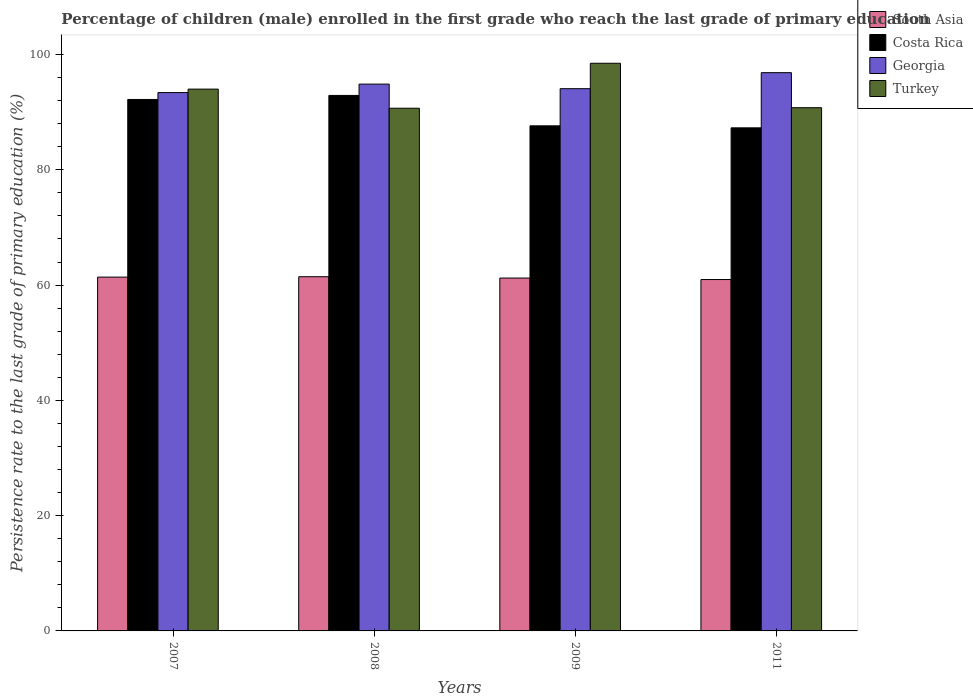Are the number of bars per tick equal to the number of legend labels?
Offer a terse response. Yes. Are the number of bars on each tick of the X-axis equal?
Offer a very short reply. Yes. In how many cases, is the number of bars for a given year not equal to the number of legend labels?
Your answer should be compact. 0. What is the persistence rate of children in Georgia in 2011?
Offer a very short reply. 96.86. Across all years, what is the maximum persistence rate of children in Turkey?
Your answer should be very brief. 98.49. Across all years, what is the minimum persistence rate of children in South Asia?
Give a very brief answer. 60.96. In which year was the persistence rate of children in Turkey maximum?
Offer a terse response. 2009. In which year was the persistence rate of children in Turkey minimum?
Ensure brevity in your answer.  2008. What is the total persistence rate of children in Georgia in the graph?
Make the answer very short. 379.2. What is the difference between the persistence rate of children in Georgia in 2007 and that in 2009?
Offer a very short reply. -0.68. What is the difference between the persistence rate of children in South Asia in 2008 and the persistence rate of children in Turkey in 2009?
Keep it short and to the point. -37.04. What is the average persistence rate of children in Georgia per year?
Ensure brevity in your answer.  94.8. In the year 2008, what is the difference between the persistence rate of children in Georgia and persistence rate of children in Costa Rica?
Provide a short and direct response. 1.96. What is the ratio of the persistence rate of children in Georgia in 2008 to that in 2011?
Ensure brevity in your answer.  0.98. Is the persistence rate of children in Turkey in 2008 less than that in 2009?
Your answer should be very brief. Yes. What is the difference between the highest and the second highest persistence rate of children in Georgia?
Your response must be concise. 1.99. What is the difference between the highest and the lowest persistence rate of children in Turkey?
Offer a terse response. 7.8. In how many years, is the persistence rate of children in Costa Rica greater than the average persistence rate of children in Costa Rica taken over all years?
Your answer should be very brief. 2. Is the sum of the persistence rate of children in Georgia in 2008 and 2009 greater than the maximum persistence rate of children in Costa Rica across all years?
Offer a terse response. Yes. What does the 3rd bar from the right in 2007 represents?
Your answer should be very brief. Costa Rica. Is it the case that in every year, the sum of the persistence rate of children in South Asia and persistence rate of children in Costa Rica is greater than the persistence rate of children in Turkey?
Your response must be concise. Yes. Are all the bars in the graph horizontal?
Give a very brief answer. No. How many years are there in the graph?
Your response must be concise. 4. What is the difference between two consecutive major ticks on the Y-axis?
Keep it short and to the point. 20. Does the graph contain any zero values?
Offer a terse response. No. Where does the legend appear in the graph?
Make the answer very short. Top right. How many legend labels are there?
Keep it short and to the point. 4. How are the legend labels stacked?
Your response must be concise. Vertical. What is the title of the graph?
Give a very brief answer. Percentage of children (male) enrolled in the first grade who reach the last grade of primary education. Does "Liechtenstein" appear as one of the legend labels in the graph?
Ensure brevity in your answer.  No. What is the label or title of the Y-axis?
Offer a very short reply. Persistence rate to the last grade of primary education (%). What is the Persistence rate to the last grade of primary education (%) of South Asia in 2007?
Your answer should be very brief. 61.38. What is the Persistence rate to the last grade of primary education (%) of Costa Rica in 2007?
Your response must be concise. 92.21. What is the Persistence rate to the last grade of primary education (%) of Georgia in 2007?
Make the answer very short. 93.4. What is the Persistence rate to the last grade of primary education (%) of Turkey in 2007?
Your answer should be compact. 94. What is the Persistence rate to the last grade of primary education (%) of South Asia in 2008?
Give a very brief answer. 61.45. What is the Persistence rate to the last grade of primary education (%) of Costa Rica in 2008?
Offer a terse response. 92.91. What is the Persistence rate to the last grade of primary education (%) in Georgia in 2008?
Your answer should be very brief. 94.87. What is the Persistence rate to the last grade of primary education (%) of Turkey in 2008?
Provide a succinct answer. 90.68. What is the Persistence rate to the last grade of primary education (%) of South Asia in 2009?
Make the answer very short. 61.22. What is the Persistence rate to the last grade of primary education (%) of Costa Rica in 2009?
Offer a very short reply. 87.63. What is the Persistence rate to the last grade of primary education (%) of Georgia in 2009?
Provide a succinct answer. 94.08. What is the Persistence rate to the last grade of primary education (%) in Turkey in 2009?
Offer a very short reply. 98.49. What is the Persistence rate to the last grade of primary education (%) in South Asia in 2011?
Your answer should be compact. 60.96. What is the Persistence rate to the last grade of primary education (%) of Costa Rica in 2011?
Provide a short and direct response. 87.28. What is the Persistence rate to the last grade of primary education (%) of Georgia in 2011?
Ensure brevity in your answer.  96.86. What is the Persistence rate to the last grade of primary education (%) in Turkey in 2011?
Your answer should be compact. 90.78. Across all years, what is the maximum Persistence rate to the last grade of primary education (%) in South Asia?
Your answer should be compact. 61.45. Across all years, what is the maximum Persistence rate to the last grade of primary education (%) in Costa Rica?
Your answer should be very brief. 92.91. Across all years, what is the maximum Persistence rate to the last grade of primary education (%) in Georgia?
Offer a terse response. 96.86. Across all years, what is the maximum Persistence rate to the last grade of primary education (%) of Turkey?
Provide a succinct answer. 98.49. Across all years, what is the minimum Persistence rate to the last grade of primary education (%) of South Asia?
Make the answer very short. 60.96. Across all years, what is the minimum Persistence rate to the last grade of primary education (%) of Costa Rica?
Provide a short and direct response. 87.28. Across all years, what is the minimum Persistence rate to the last grade of primary education (%) of Georgia?
Keep it short and to the point. 93.4. Across all years, what is the minimum Persistence rate to the last grade of primary education (%) of Turkey?
Your response must be concise. 90.68. What is the total Persistence rate to the last grade of primary education (%) of South Asia in the graph?
Make the answer very short. 245.02. What is the total Persistence rate to the last grade of primary education (%) in Costa Rica in the graph?
Make the answer very short. 360.03. What is the total Persistence rate to the last grade of primary education (%) of Georgia in the graph?
Your answer should be very brief. 379.2. What is the total Persistence rate to the last grade of primary education (%) in Turkey in the graph?
Your response must be concise. 373.95. What is the difference between the Persistence rate to the last grade of primary education (%) of South Asia in 2007 and that in 2008?
Keep it short and to the point. -0.07. What is the difference between the Persistence rate to the last grade of primary education (%) of Costa Rica in 2007 and that in 2008?
Ensure brevity in your answer.  -0.7. What is the difference between the Persistence rate to the last grade of primary education (%) in Georgia in 2007 and that in 2008?
Offer a very short reply. -1.47. What is the difference between the Persistence rate to the last grade of primary education (%) in Turkey in 2007 and that in 2008?
Your answer should be compact. 3.32. What is the difference between the Persistence rate to the last grade of primary education (%) of South Asia in 2007 and that in 2009?
Provide a succinct answer. 0.16. What is the difference between the Persistence rate to the last grade of primary education (%) in Costa Rica in 2007 and that in 2009?
Provide a short and direct response. 4.58. What is the difference between the Persistence rate to the last grade of primary education (%) in Georgia in 2007 and that in 2009?
Make the answer very short. -0.68. What is the difference between the Persistence rate to the last grade of primary education (%) of Turkey in 2007 and that in 2009?
Ensure brevity in your answer.  -4.49. What is the difference between the Persistence rate to the last grade of primary education (%) of South Asia in 2007 and that in 2011?
Make the answer very short. 0.42. What is the difference between the Persistence rate to the last grade of primary education (%) in Costa Rica in 2007 and that in 2011?
Give a very brief answer. 4.92. What is the difference between the Persistence rate to the last grade of primary education (%) in Georgia in 2007 and that in 2011?
Provide a short and direct response. -3.46. What is the difference between the Persistence rate to the last grade of primary education (%) of Turkey in 2007 and that in 2011?
Give a very brief answer. 3.23. What is the difference between the Persistence rate to the last grade of primary education (%) of South Asia in 2008 and that in 2009?
Make the answer very short. 0.23. What is the difference between the Persistence rate to the last grade of primary education (%) of Costa Rica in 2008 and that in 2009?
Your answer should be compact. 5.27. What is the difference between the Persistence rate to the last grade of primary education (%) of Georgia in 2008 and that in 2009?
Provide a short and direct response. 0.79. What is the difference between the Persistence rate to the last grade of primary education (%) in Turkey in 2008 and that in 2009?
Your answer should be very brief. -7.8. What is the difference between the Persistence rate to the last grade of primary education (%) of South Asia in 2008 and that in 2011?
Your answer should be very brief. 0.49. What is the difference between the Persistence rate to the last grade of primary education (%) in Costa Rica in 2008 and that in 2011?
Give a very brief answer. 5.62. What is the difference between the Persistence rate to the last grade of primary education (%) in Georgia in 2008 and that in 2011?
Keep it short and to the point. -1.99. What is the difference between the Persistence rate to the last grade of primary education (%) of Turkey in 2008 and that in 2011?
Ensure brevity in your answer.  -0.09. What is the difference between the Persistence rate to the last grade of primary education (%) of South Asia in 2009 and that in 2011?
Provide a succinct answer. 0.26. What is the difference between the Persistence rate to the last grade of primary education (%) of Costa Rica in 2009 and that in 2011?
Give a very brief answer. 0.35. What is the difference between the Persistence rate to the last grade of primary education (%) of Georgia in 2009 and that in 2011?
Make the answer very short. -2.78. What is the difference between the Persistence rate to the last grade of primary education (%) in Turkey in 2009 and that in 2011?
Make the answer very short. 7.71. What is the difference between the Persistence rate to the last grade of primary education (%) in South Asia in 2007 and the Persistence rate to the last grade of primary education (%) in Costa Rica in 2008?
Give a very brief answer. -31.52. What is the difference between the Persistence rate to the last grade of primary education (%) of South Asia in 2007 and the Persistence rate to the last grade of primary education (%) of Georgia in 2008?
Give a very brief answer. -33.49. What is the difference between the Persistence rate to the last grade of primary education (%) of South Asia in 2007 and the Persistence rate to the last grade of primary education (%) of Turkey in 2008?
Give a very brief answer. -29.3. What is the difference between the Persistence rate to the last grade of primary education (%) of Costa Rica in 2007 and the Persistence rate to the last grade of primary education (%) of Georgia in 2008?
Provide a succinct answer. -2.66. What is the difference between the Persistence rate to the last grade of primary education (%) in Costa Rica in 2007 and the Persistence rate to the last grade of primary education (%) in Turkey in 2008?
Make the answer very short. 1.52. What is the difference between the Persistence rate to the last grade of primary education (%) in Georgia in 2007 and the Persistence rate to the last grade of primary education (%) in Turkey in 2008?
Offer a very short reply. 2.71. What is the difference between the Persistence rate to the last grade of primary education (%) of South Asia in 2007 and the Persistence rate to the last grade of primary education (%) of Costa Rica in 2009?
Ensure brevity in your answer.  -26.25. What is the difference between the Persistence rate to the last grade of primary education (%) of South Asia in 2007 and the Persistence rate to the last grade of primary education (%) of Georgia in 2009?
Keep it short and to the point. -32.69. What is the difference between the Persistence rate to the last grade of primary education (%) in South Asia in 2007 and the Persistence rate to the last grade of primary education (%) in Turkey in 2009?
Your response must be concise. -37.1. What is the difference between the Persistence rate to the last grade of primary education (%) in Costa Rica in 2007 and the Persistence rate to the last grade of primary education (%) in Georgia in 2009?
Your answer should be compact. -1.87. What is the difference between the Persistence rate to the last grade of primary education (%) of Costa Rica in 2007 and the Persistence rate to the last grade of primary education (%) of Turkey in 2009?
Provide a short and direct response. -6.28. What is the difference between the Persistence rate to the last grade of primary education (%) of Georgia in 2007 and the Persistence rate to the last grade of primary education (%) of Turkey in 2009?
Provide a short and direct response. -5.09. What is the difference between the Persistence rate to the last grade of primary education (%) of South Asia in 2007 and the Persistence rate to the last grade of primary education (%) of Costa Rica in 2011?
Offer a very short reply. -25.9. What is the difference between the Persistence rate to the last grade of primary education (%) in South Asia in 2007 and the Persistence rate to the last grade of primary education (%) in Georgia in 2011?
Your answer should be compact. -35.47. What is the difference between the Persistence rate to the last grade of primary education (%) in South Asia in 2007 and the Persistence rate to the last grade of primary education (%) in Turkey in 2011?
Your answer should be very brief. -29.39. What is the difference between the Persistence rate to the last grade of primary education (%) of Costa Rica in 2007 and the Persistence rate to the last grade of primary education (%) of Georgia in 2011?
Offer a very short reply. -4.65. What is the difference between the Persistence rate to the last grade of primary education (%) in Costa Rica in 2007 and the Persistence rate to the last grade of primary education (%) in Turkey in 2011?
Provide a short and direct response. 1.43. What is the difference between the Persistence rate to the last grade of primary education (%) of Georgia in 2007 and the Persistence rate to the last grade of primary education (%) of Turkey in 2011?
Offer a terse response. 2.62. What is the difference between the Persistence rate to the last grade of primary education (%) of South Asia in 2008 and the Persistence rate to the last grade of primary education (%) of Costa Rica in 2009?
Offer a terse response. -26.18. What is the difference between the Persistence rate to the last grade of primary education (%) of South Asia in 2008 and the Persistence rate to the last grade of primary education (%) of Georgia in 2009?
Give a very brief answer. -32.63. What is the difference between the Persistence rate to the last grade of primary education (%) in South Asia in 2008 and the Persistence rate to the last grade of primary education (%) in Turkey in 2009?
Keep it short and to the point. -37.04. What is the difference between the Persistence rate to the last grade of primary education (%) in Costa Rica in 2008 and the Persistence rate to the last grade of primary education (%) in Georgia in 2009?
Give a very brief answer. -1.17. What is the difference between the Persistence rate to the last grade of primary education (%) of Costa Rica in 2008 and the Persistence rate to the last grade of primary education (%) of Turkey in 2009?
Ensure brevity in your answer.  -5.58. What is the difference between the Persistence rate to the last grade of primary education (%) of Georgia in 2008 and the Persistence rate to the last grade of primary education (%) of Turkey in 2009?
Make the answer very short. -3.62. What is the difference between the Persistence rate to the last grade of primary education (%) in South Asia in 2008 and the Persistence rate to the last grade of primary education (%) in Costa Rica in 2011?
Offer a very short reply. -25.83. What is the difference between the Persistence rate to the last grade of primary education (%) of South Asia in 2008 and the Persistence rate to the last grade of primary education (%) of Georgia in 2011?
Give a very brief answer. -35.4. What is the difference between the Persistence rate to the last grade of primary education (%) in South Asia in 2008 and the Persistence rate to the last grade of primary education (%) in Turkey in 2011?
Provide a short and direct response. -29.32. What is the difference between the Persistence rate to the last grade of primary education (%) in Costa Rica in 2008 and the Persistence rate to the last grade of primary education (%) in Georgia in 2011?
Your response must be concise. -3.95. What is the difference between the Persistence rate to the last grade of primary education (%) of Costa Rica in 2008 and the Persistence rate to the last grade of primary education (%) of Turkey in 2011?
Your answer should be very brief. 2.13. What is the difference between the Persistence rate to the last grade of primary education (%) of Georgia in 2008 and the Persistence rate to the last grade of primary education (%) of Turkey in 2011?
Ensure brevity in your answer.  4.1. What is the difference between the Persistence rate to the last grade of primary education (%) in South Asia in 2009 and the Persistence rate to the last grade of primary education (%) in Costa Rica in 2011?
Your answer should be very brief. -26.06. What is the difference between the Persistence rate to the last grade of primary education (%) in South Asia in 2009 and the Persistence rate to the last grade of primary education (%) in Georgia in 2011?
Provide a succinct answer. -35.63. What is the difference between the Persistence rate to the last grade of primary education (%) of South Asia in 2009 and the Persistence rate to the last grade of primary education (%) of Turkey in 2011?
Provide a succinct answer. -29.55. What is the difference between the Persistence rate to the last grade of primary education (%) in Costa Rica in 2009 and the Persistence rate to the last grade of primary education (%) in Georgia in 2011?
Give a very brief answer. -9.22. What is the difference between the Persistence rate to the last grade of primary education (%) of Costa Rica in 2009 and the Persistence rate to the last grade of primary education (%) of Turkey in 2011?
Provide a succinct answer. -3.14. What is the difference between the Persistence rate to the last grade of primary education (%) in Georgia in 2009 and the Persistence rate to the last grade of primary education (%) in Turkey in 2011?
Offer a very short reply. 3.3. What is the average Persistence rate to the last grade of primary education (%) in South Asia per year?
Provide a short and direct response. 61.26. What is the average Persistence rate to the last grade of primary education (%) in Costa Rica per year?
Your answer should be very brief. 90.01. What is the average Persistence rate to the last grade of primary education (%) in Georgia per year?
Your response must be concise. 94.8. What is the average Persistence rate to the last grade of primary education (%) in Turkey per year?
Your response must be concise. 93.49. In the year 2007, what is the difference between the Persistence rate to the last grade of primary education (%) of South Asia and Persistence rate to the last grade of primary education (%) of Costa Rica?
Provide a succinct answer. -30.82. In the year 2007, what is the difference between the Persistence rate to the last grade of primary education (%) of South Asia and Persistence rate to the last grade of primary education (%) of Georgia?
Offer a very short reply. -32.02. In the year 2007, what is the difference between the Persistence rate to the last grade of primary education (%) of South Asia and Persistence rate to the last grade of primary education (%) of Turkey?
Your response must be concise. -32.62. In the year 2007, what is the difference between the Persistence rate to the last grade of primary education (%) of Costa Rica and Persistence rate to the last grade of primary education (%) of Georgia?
Offer a very short reply. -1.19. In the year 2007, what is the difference between the Persistence rate to the last grade of primary education (%) in Costa Rica and Persistence rate to the last grade of primary education (%) in Turkey?
Offer a very short reply. -1.79. In the year 2007, what is the difference between the Persistence rate to the last grade of primary education (%) of Georgia and Persistence rate to the last grade of primary education (%) of Turkey?
Keep it short and to the point. -0.6. In the year 2008, what is the difference between the Persistence rate to the last grade of primary education (%) in South Asia and Persistence rate to the last grade of primary education (%) in Costa Rica?
Ensure brevity in your answer.  -31.45. In the year 2008, what is the difference between the Persistence rate to the last grade of primary education (%) of South Asia and Persistence rate to the last grade of primary education (%) of Georgia?
Provide a succinct answer. -33.42. In the year 2008, what is the difference between the Persistence rate to the last grade of primary education (%) in South Asia and Persistence rate to the last grade of primary education (%) in Turkey?
Your answer should be compact. -29.23. In the year 2008, what is the difference between the Persistence rate to the last grade of primary education (%) in Costa Rica and Persistence rate to the last grade of primary education (%) in Georgia?
Give a very brief answer. -1.96. In the year 2008, what is the difference between the Persistence rate to the last grade of primary education (%) in Costa Rica and Persistence rate to the last grade of primary education (%) in Turkey?
Offer a very short reply. 2.22. In the year 2008, what is the difference between the Persistence rate to the last grade of primary education (%) in Georgia and Persistence rate to the last grade of primary education (%) in Turkey?
Keep it short and to the point. 4.19. In the year 2009, what is the difference between the Persistence rate to the last grade of primary education (%) in South Asia and Persistence rate to the last grade of primary education (%) in Costa Rica?
Your answer should be very brief. -26.41. In the year 2009, what is the difference between the Persistence rate to the last grade of primary education (%) in South Asia and Persistence rate to the last grade of primary education (%) in Georgia?
Provide a succinct answer. -32.85. In the year 2009, what is the difference between the Persistence rate to the last grade of primary education (%) in South Asia and Persistence rate to the last grade of primary education (%) in Turkey?
Keep it short and to the point. -37.27. In the year 2009, what is the difference between the Persistence rate to the last grade of primary education (%) in Costa Rica and Persistence rate to the last grade of primary education (%) in Georgia?
Offer a very short reply. -6.45. In the year 2009, what is the difference between the Persistence rate to the last grade of primary education (%) of Costa Rica and Persistence rate to the last grade of primary education (%) of Turkey?
Your answer should be compact. -10.86. In the year 2009, what is the difference between the Persistence rate to the last grade of primary education (%) in Georgia and Persistence rate to the last grade of primary education (%) in Turkey?
Give a very brief answer. -4.41. In the year 2011, what is the difference between the Persistence rate to the last grade of primary education (%) of South Asia and Persistence rate to the last grade of primary education (%) of Costa Rica?
Ensure brevity in your answer.  -26.32. In the year 2011, what is the difference between the Persistence rate to the last grade of primary education (%) in South Asia and Persistence rate to the last grade of primary education (%) in Georgia?
Your response must be concise. -35.89. In the year 2011, what is the difference between the Persistence rate to the last grade of primary education (%) in South Asia and Persistence rate to the last grade of primary education (%) in Turkey?
Your answer should be very brief. -29.81. In the year 2011, what is the difference between the Persistence rate to the last grade of primary education (%) of Costa Rica and Persistence rate to the last grade of primary education (%) of Georgia?
Ensure brevity in your answer.  -9.57. In the year 2011, what is the difference between the Persistence rate to the last grade of primary education (%) of Costa Rica and Persistence rate to the last grade of primary education (%) of Turkey?
Give a very brief answer. -3.49. In the year 2011, what is the difference between the Persistence rate to the last grade of primary education (%) in Georgia and Persistence rate to the last grade of primary education (%) in Turkey?
Your answer should be compact. 6.08. What is the ratio of the Persistence rate to the last grade of primary education (%) in Georgia in 2007 to that in 2008?
Provide a short and direct response. 0.98. What is the ratio of the Persistence rate to the last grade of primary education (%) in Turkey in 2007 to that in 2008?
Provide a short and direct response. 1.04. What is the ratio of the Persistence rate to the last grade of primary education (%) in South Asia in 2007 to that in 2009?
Provide a short and direct response. 1. What is the ratio of the Persistence rate to the last grade of primary education (%) of Costa Rica in 2007 to that in 2009?
Offer a terse response. 1.05. What is the ratio of the Persistence rate to the last grade of primary education (%) of Georgia in 2007 to that in 2009?
Your answer should be very brief. 0.99. What is the ratio of the Persistence rate to the last grade of primary education (%) in Turkey in 2007 to that in 2009?
Offer a very short reply. 0.95. What is the ratio of the Persistence rate to the last grade of primary education (%) in Costa Rica in 2007 to that in 2011?
Your response must be concise. 1.06. What is the ratio of the Persistence rate to the last grade of primary education (%) in Turkey in 2007 to that in 2011?
Ensure brevity in your answer.  1.04. What is the ratio of the Persistence rate to the last grade of primary education (%) of Costa Rica in 2008 to that in 2009?
Make the answer very short. 1.06. What is the ratio of the Persistence rate to the last grade of primary education (%) of Georgia in 2008 to that in 2009?
Provide a succinct answer. 1.01. What is the ratio of the Persistence rate to the last grade of primary education (%) of Turkey in 2008 to that in 2009?
Offer a very short reply. 0.92. What is the ratio of the Persistence rate to the last grade of primary education (%) in Costa Rica in 2008 to that in 2011?
Keep it short and to the point. 1.06. What is the ratio of the Persistence rate to the last grade of primary education (%) in Georgia in 2008 to that in 2011?
Your response must be concise. 0.98. What is the ratio of the Persistence rate to the last grade of primary education (%) of South Asia in 2009 to that in 2011?
Your answer should be very brief. 1. What is the ratio of the Persistence rate to the last grade of primary education (%) of Georgia in 2009 to that in 2011?
Your answer should be very brief. 0.97. What is the ratio of the Persistence rate to the last grade of primary education (%) in Turkey in 2009 to that in 2011?
Your response must be concise. 1.08. What is the difference between the highest and the second highest Persistence rate to the last grade of primary education (%) in South Asia?
Your response must be concise. 0.07. What is the difference between the highest and the second highest Persistence rate to the last grade of primary education (%) in Costa Rica?
Give a very brief answer. 0.7. What is the difference between the highest and the second highest Persistence rate to the last grade of primary education (%) in Georgia?
Offer a terse response. 1.99. What is the difference between the highest and the second highest Persistence rate to the last grade of primary education (%) of Turkey?
Give a very brief answer. 4.49. What is the difference between the highest and the lowest Persistence rate to the last grade of primary education (%) in South Asia?
Make the answer very short. 0.49. What is the difference between the highest and the lowest Persistence rate to the last grade of primary education (%) in Costa Rica?
Your answer should be very brief. 5.62. What is the difference between the highest and the lowest Persistence rate to the last grade of primary education (%) of Georgia?
Keep it short and to the point. 3.46. What is the difference between the highest and the lowest Persistence rate to the last grade of primary education (%) of Turkey?
Your response must be concise. 7.8. 